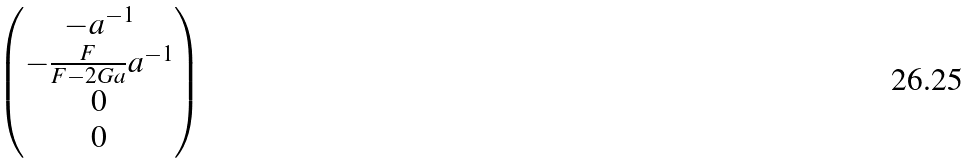<formula> <loc_0><loc_0><loc_500><loc_500>\begin{pmatrix} - a ^ { - 1 } \\ - \frac { F } { F - 2 G a } a ^ { - 1 } \\ 0 \\ 0 \end{pmatrix}</formula> 